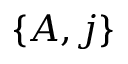<formula> <loc_0><loc_0><loc_500><loc_500>\{ A , j \}</formula> 